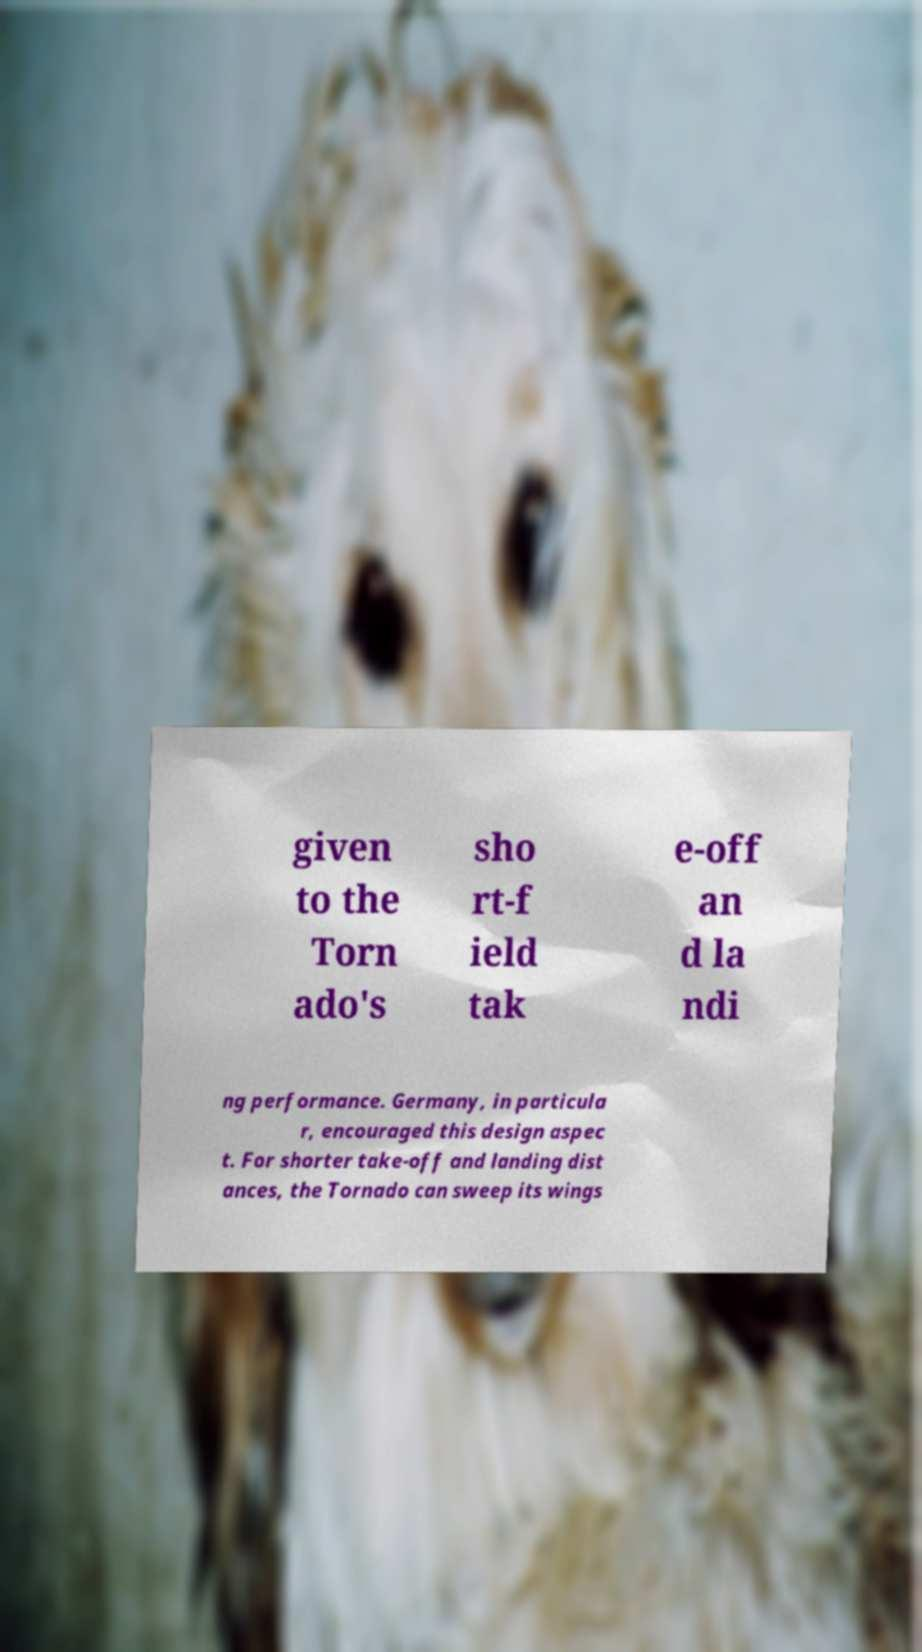Please identify and transcribe the text found in this image. given to the Torn ado's sho rt-f ield tak e-off an d la ndi ng performance. Germany, in particula r, encouraged this design aspec t. For shorter take-off and landing dist ances, the Tornado can sweep its wings 